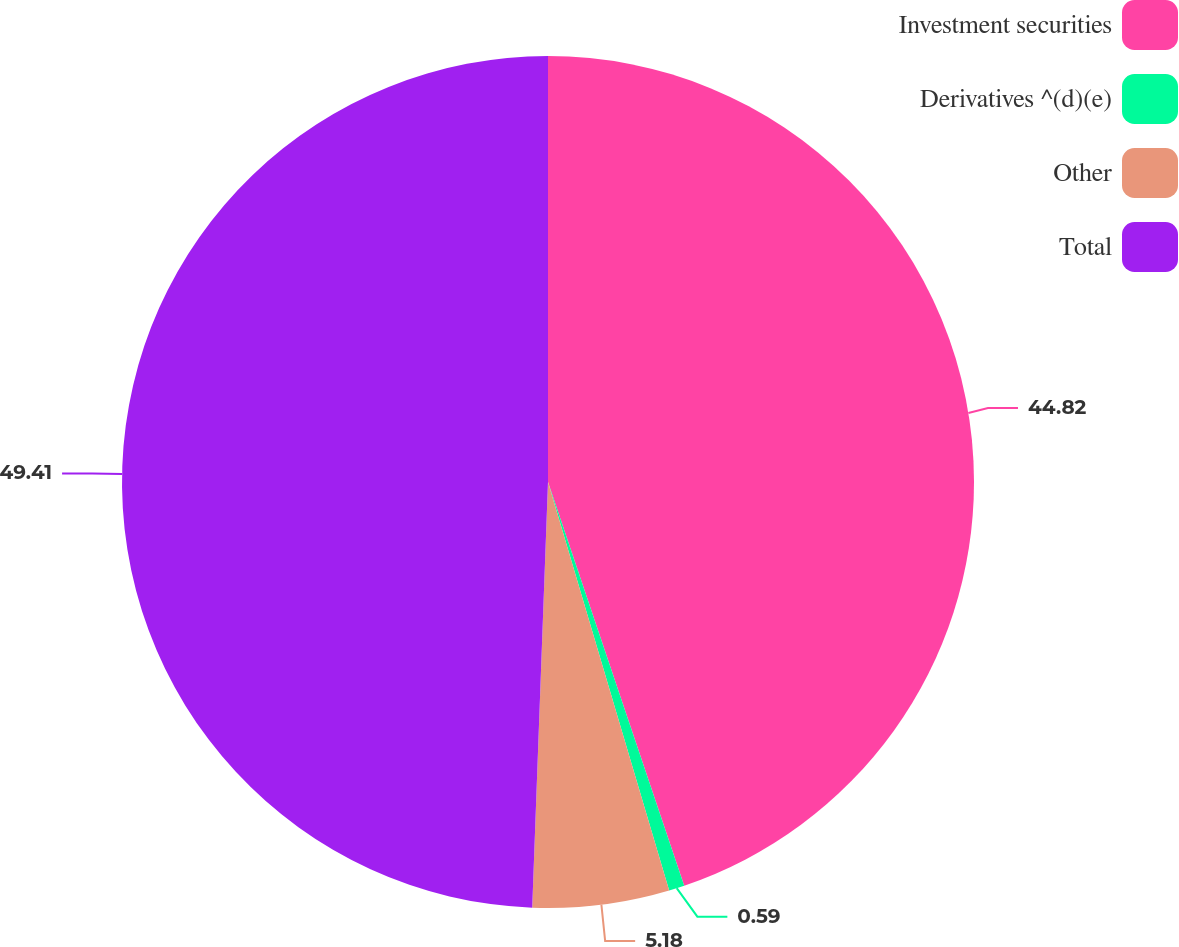<chart> <loc_0><loc_0><loc_500><loc_500><pie_chart><fcel>Investment securities<fcel>Derivatives ^(d)(e)<fcel>Other<fcel>Total<nl><fcel>44.82%<fcel>0.59%<fcel>5.18%<fcel>49.41%<nl></chart> 